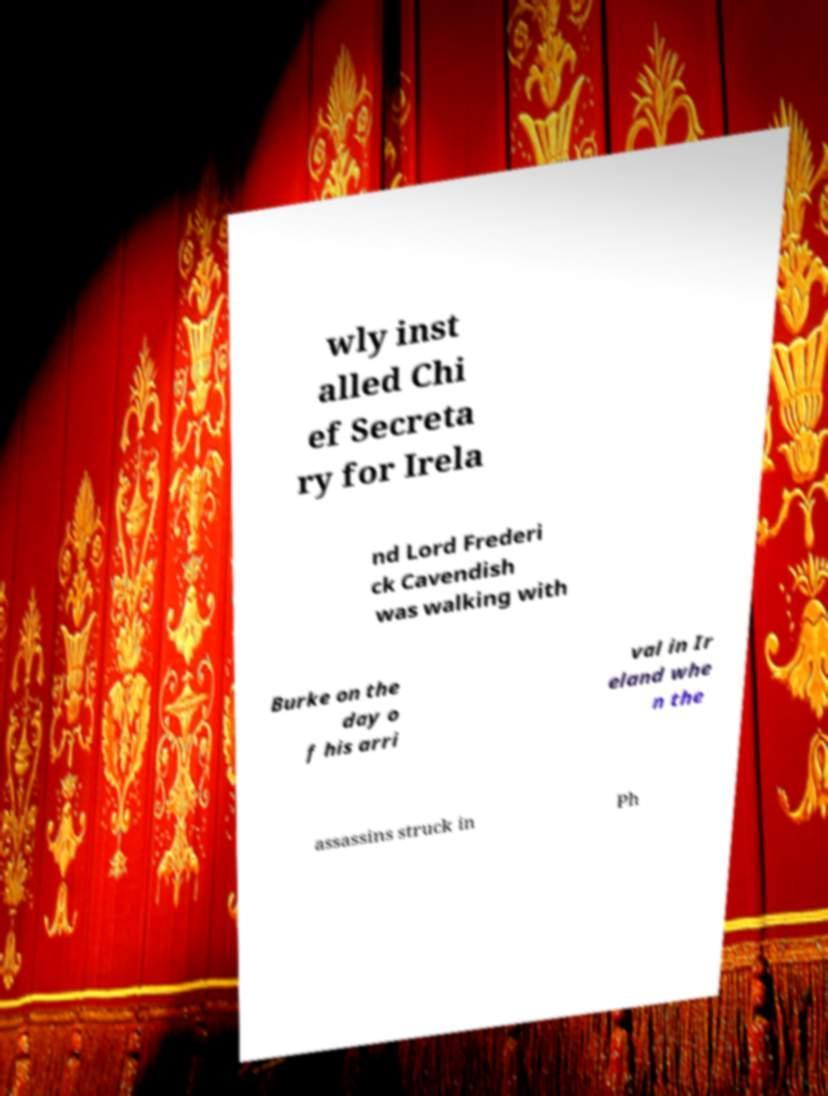Please read and relay the text visible in this image. What does it say? wly inst alled Chi ef Secreta ry for Irela nd Lord Frederi ck Cavendish was walking with Burke on the day o f his arri val in Ir eland whe n the assassins struck in Ph 